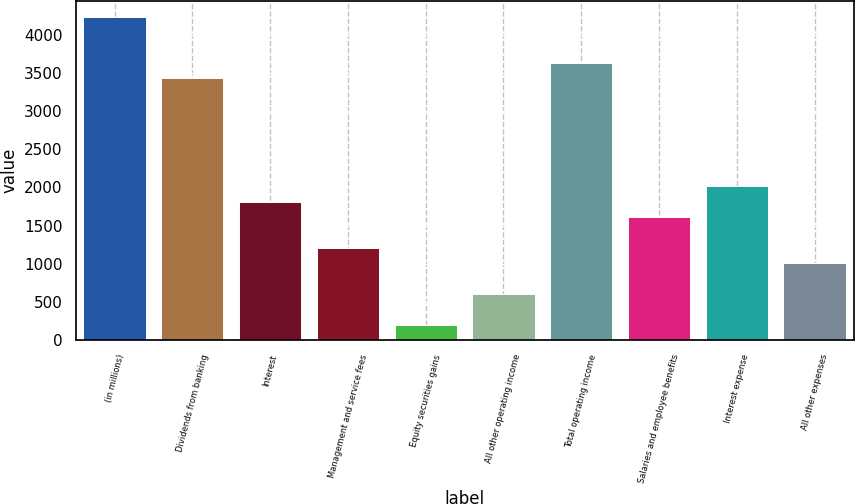<chart> <loc_0><loc_0><loc_500><loc_500><bar_chart><fcel>(in millions)<fcel>Dividends from banking<fcel>Interest<fcel>Management and service fees<fcel>Equity securities gains<fcel>All other operating income<fcel>Total operating income<fcel>Salaries and employee benefits<fcel>Interest expense<fcel>All other expenses<nl><fcel>4231.4<fcel>3425.8<fcel>1814.6<fcel>1210.4<fcel>203.4<fcel>606.2<fcel>3627.2<fcel>1613.2<fcel>2016<fcel>1009<nl></chart> 